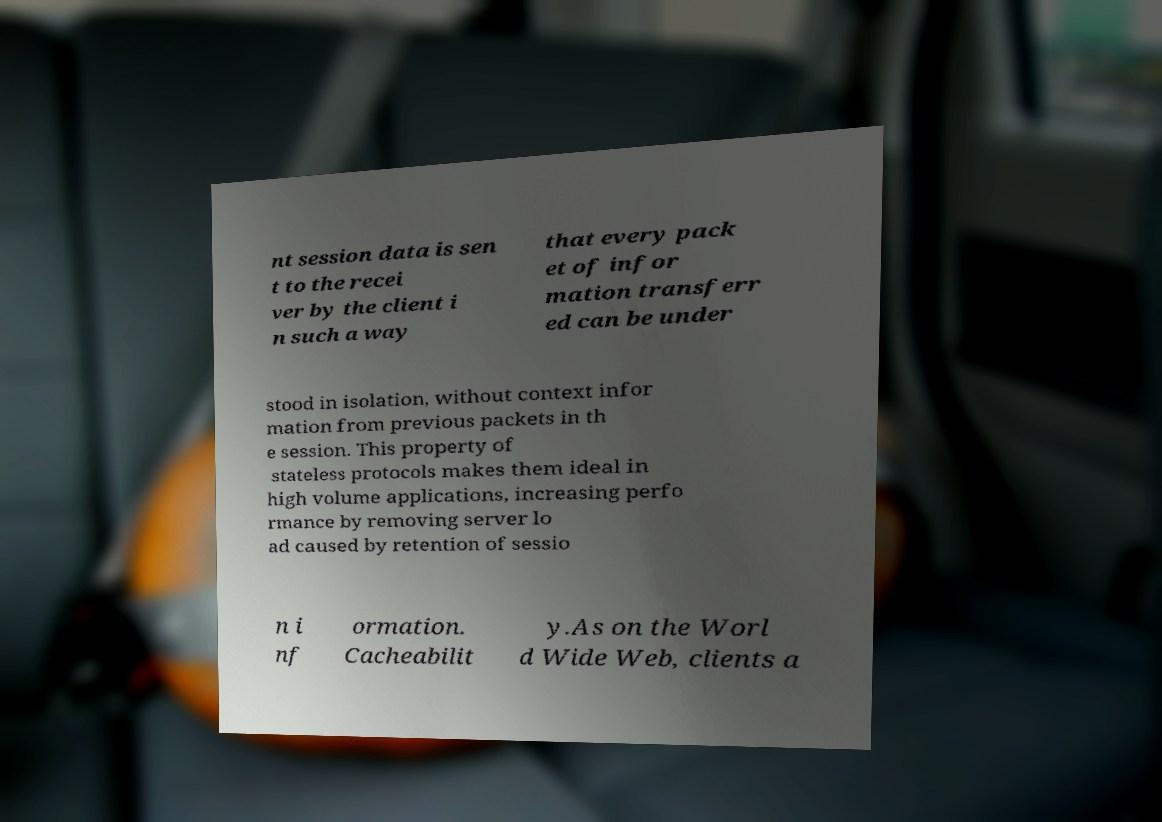For documentation purposes, I need the text within this image transcribed. Could you provide that? nt session data is sen t to the recei ver by the client i n such a way that every pack et of infor mation transferr ed can be under stood in isolation, without context infor mation from previous packets in th e session. This property of stateless protocols makes them ideal in high volume applications, increasing perfo rmance by removing server lo ad caused by retention of sessio n i nf ormation. Cacheabilit y.As on the Worl d Wide Web, clients a 